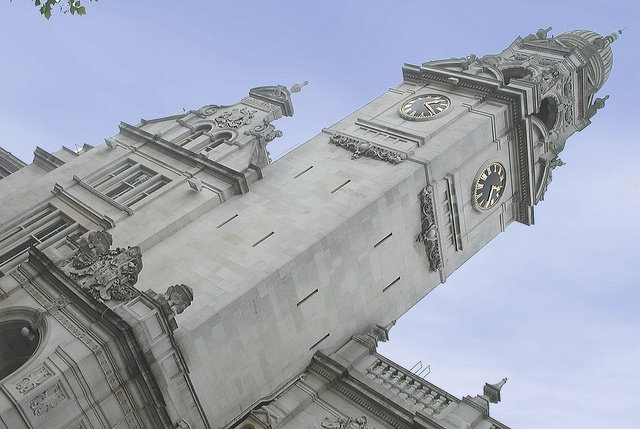Describe the objects in this image and their specific colors. I can see clock in lavender, gray, darkgray, ivory, and black tones and clock in lavender, darkgray, gray, and lightgray tones in this image. 